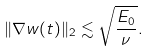Convert formula to latex. <formula><loc_0><loc_0><loc_500><loc_500>\| \nabla w ( t ) \| _ { 2 } \lesssim \sqrt { \frac { E _ { 0 } } { \nu } } .</formula> 